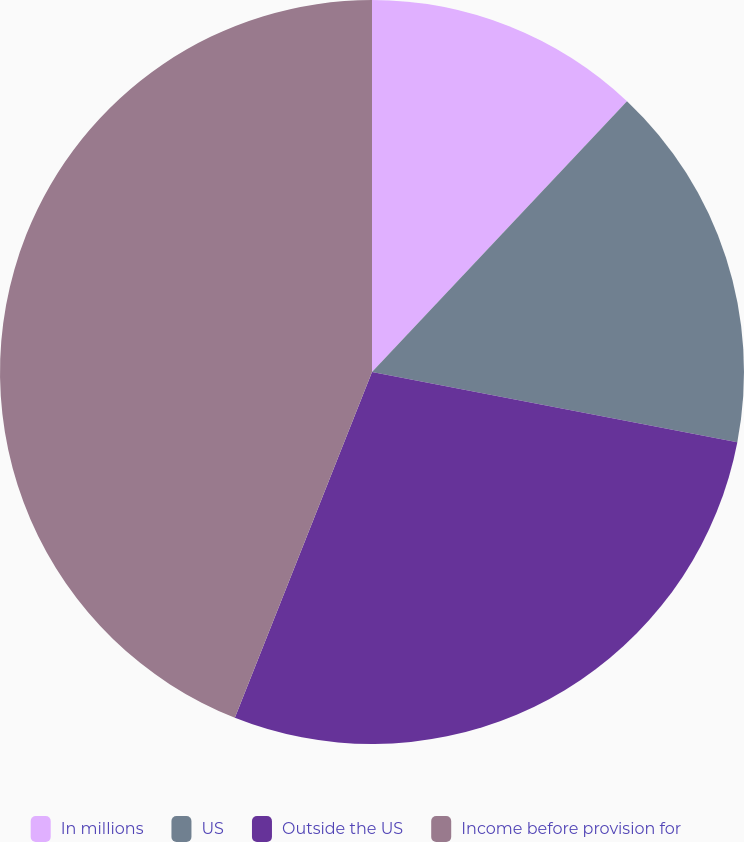Convert chart. <chart><loc_0><loc_0><loc_500><loc_500><pie_chart><fcel>In millions<fcel>US<fcel>Outside the US<fcel>Income before provision for<nl><fcel>12.02%<fcel>16.0%<fcel>27.99%<fcel>43.99%<nl></chart> 